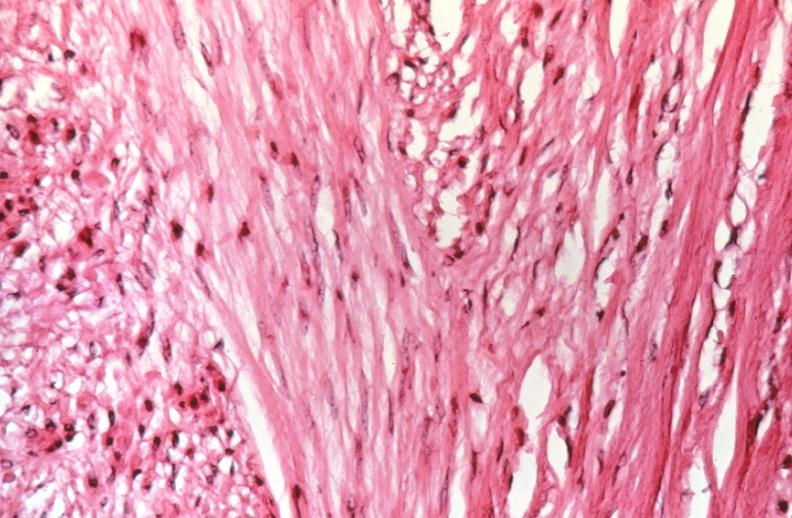s female reproductive present?
Answer the question using a single word or phrase. Yes 